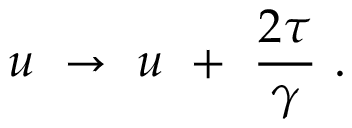Convert formula to latex. <formula><loc_0><loc_0><loc_500><loc_500>u \to u + { \frac { 2 \tau } { \gamma } } \ .</formula> 